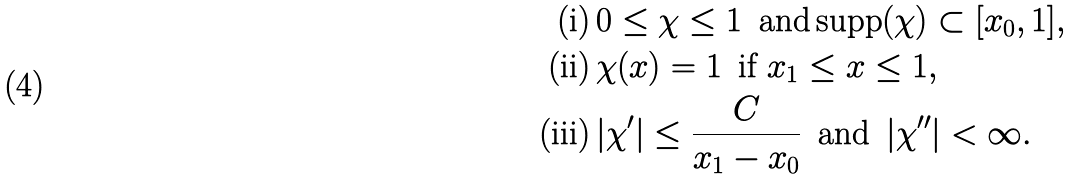Convert formula to latex. <formula><loc_0><loc_0><loc_500><loc_500>\text {(i)} & \, 0 \leq \chi \leq 1 \, \text { and} \, \text {supp} ( \chi ) \subset [ x _ { 0 } , 1 ] , \\ \text {(ii)} & \, \chi ( x ) = 1 \, \text { if } x _ { 1 } \leq x \leq 1 , \\ \text {(iii)} & \, | \chi ^ { \prime } | \leq \frac { C } { x _ { 1 } - x _ { 0 } } \, \text { and } \, | \chi ^ { \prime \prime } | < \infty .</formula> 